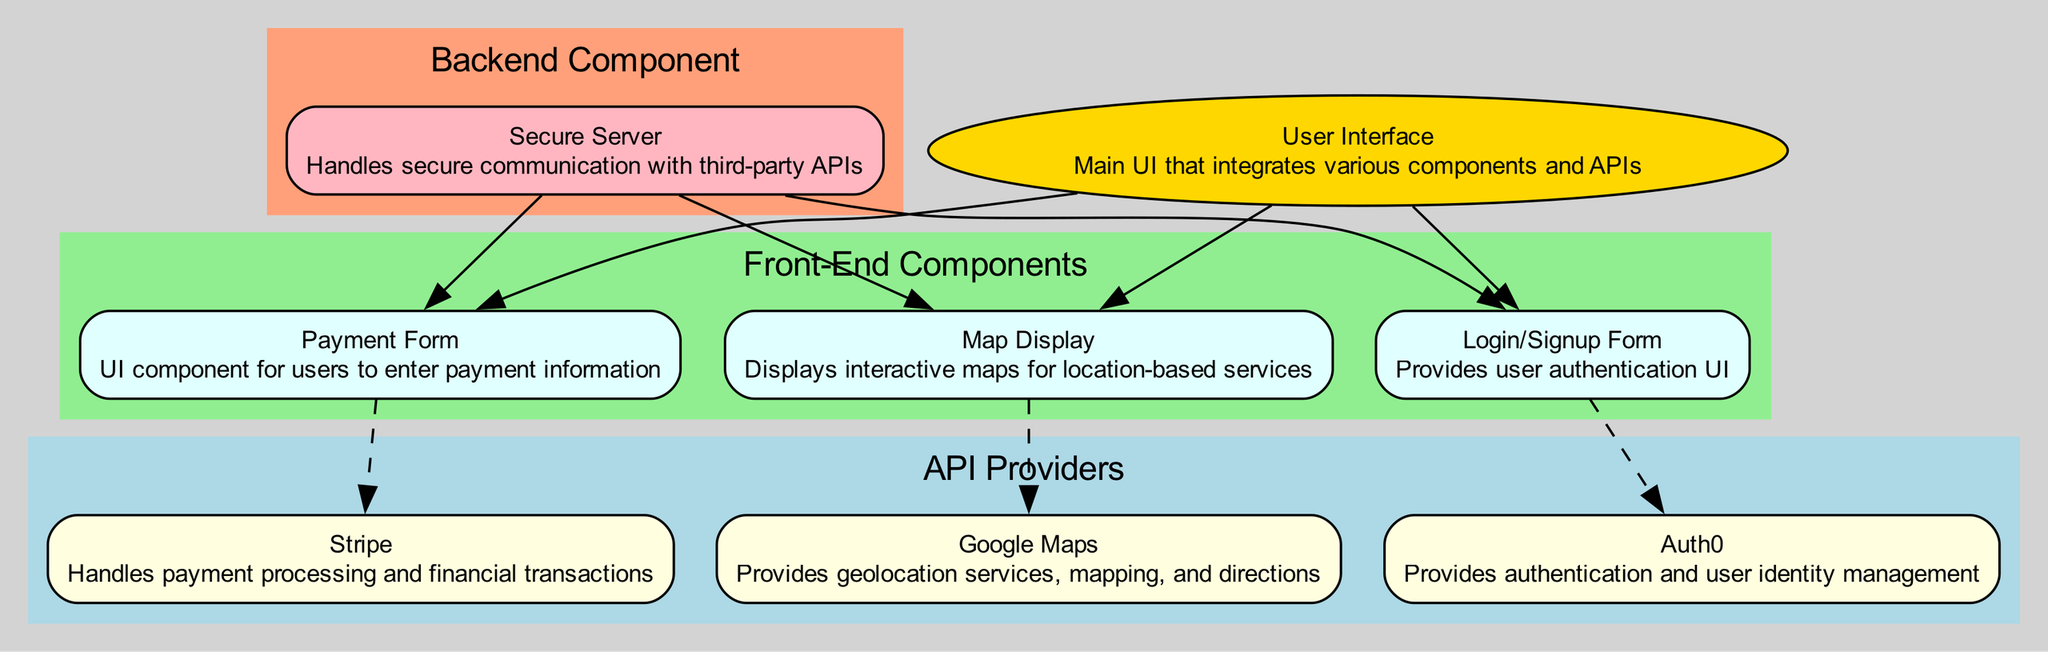What is the name of the API provider that handles payment processing? The diagram includes an API provider named "Stripe," which is specifically described as handling payment processing and financial transactions.
Answer: Stripe How many front-end components are integrated with backend components? There are three front-end components: "Payment Form," "Map Display," and "Login/Signup Form." Each is connected to the "Secure Server," making a total of three integrations.
Answer: 3 Which front-end component integrates with Google Maps? The front-end component named "Map Display" is explicitly stated to integrate with the Google Maps API, which provides geolocation services.
Answer: Map Display What is the primary purpose of the "Login/Signup Form"? According to the diagram, the "Login/Signup Form" is described as providing user authentication UI, indicating its primary purpose is to facilitate user login and registration.
Answer: User authentication Which API provider is responsible for user identity management? The API provider "Auth0" is identified in the diagram as offering authentication and user identity management services, thus fulfilling this role.
Answer: Auth0 How many edges lead from the "User Interface" to front-end components? The "User Interface" is directly connected to all three front-end components, meaning there are three edges leading out from the "User Interface" node.
Answer: 3 Which component provides data to the "Payment Form"? The "Secure Server" is indicated as providing data to the "Payment Form," as per the connections shown in the diagram, serving as a backend component.
Answer: Secure Server What type of node is the "User Interface"? The "User Interface" is represented as an ellipse shape in the diagram, indicating that it is classified as a main node integrating various components and APIs.
Answer: Ellipse What color is used for the "Front-End Components" in the diagram? The diagram visually represents "Front-End Components" in light green, indicating their category and status within the overall structure.
Answer: Light green 